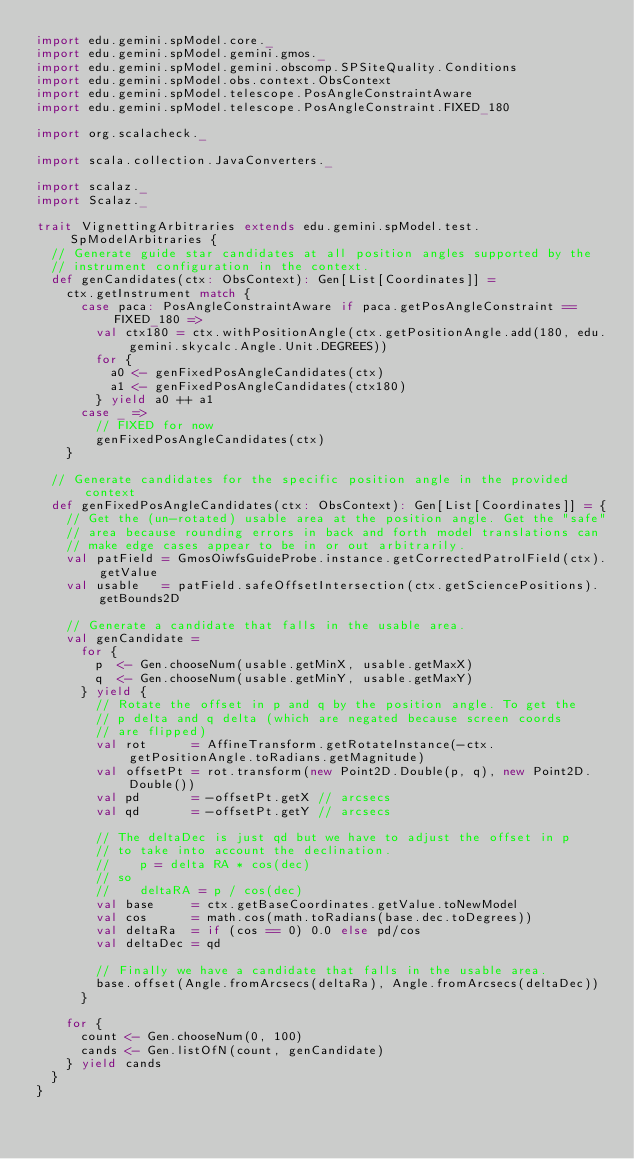Convert code to text. <code><loc_0><loc_0><loc_500><loc_500><_Scala_>import edu.gemini.spModel.core._
import edu.gemini.spModel.gemini.gmos._
import edu.gemini.spModel.gemini.obscomp.SPSiteQuality.Conditions
import edu.gemini.spModel.obs.context.ObsContext
import edu.gemini.spModel.telescope.PosAngleConstraintAware
import edu.gemini.spModel.telescope.PosAngleConstraint.FIXED_180

import org.scalacheck._

import scala.collection.JavaConverters._

import scalaz._
import Scalaz._

trait VignettingArbitraries extends edu.gemini.spModel.test.SpModelArbitraries {
  // Generate guide star candidates at all position angles supported by the
  // instrument configuration in the context.
  def genCandidates(ctx: ObsContext): Gen[List[Coordinates]] =
    ctx.getInstrument match {
      case paca: PosAngleConstraintAware if paca.getPosAngleConstraint == FIXED_180 =>
        val ctx180 = ctx.withPositionAngle(ctx.getPositionAngle.add(180, edu.gemini.skycalc.Angle.Unit.DEGREES))
        for {
          a0 <- genFixedPosAngleCandidates(ctx)
          a1 <- genFixedPosAngleCandidates(ctx180)
        } yield a0 ++ a1
      case _ =>
        // FIXED for now
        genFixedPosAngleCandidates(ctx)
    }

  // Generate candidates for the specific position angle in the provided context
  def genFixedPosAngleCandidates(ctx: ObsContext): Gen[List[Coordinates]] = {
    // Get the (un-rotated) usable area at the position angle. Get the "safe"
    // area because rounding errors in back and forth model translations can
    // make edge cases appear to be in or out arbitrarily.
    val patField = GmosOiwfsGuideProbe.instance.getCorrectedPatrolField(ctx).getValue
    val usable   = patField.safeOffsetIntersection(ctx.getSciencePositions).getBounds2D

    // Generate a candidate that falls in the usable area.
    val genCandidate =
      for {
        p  <- Gen.chooseNum(usable.getMinX, usable.getMaxX)
        q  <- Gen.chooseNum(usable.getMinY, usable.getMaxY)
      } yield {
        // Rotate the offset in p and q by the position angle. To get the
        // p delta and q delta (which are negated because screen coords
        // are flipped)
        val rot      = AffineTransform.getRotateInstance(-ctx.getPositionAngle.toRadians.getMagnitude)
        val offsetPt = rot.transform(new Point2D.Double(p, q), new Point2D.Double())
        val pd       = -offsetPt.getX // arcsecs
        val qd       = -offsetPt.getY // arcsecs

        // The deltaDec is just qd but we have to adjust the offset in p
        // to take into account the declination.
        //    p = delta RA * cos(dec)
        // so
        //    deltaRA = p / cos(dec)
        val base     = ctx.getBaseCoordinates.getValue.toNewModel
        val cos      = math.cos(math.toRadians(base.dec.toDegrees))
        val deltaRa  = if (cos == 0) 0.0 else pd/cos
        val deltaDec = qd

        // Finally we have a candidate that falls in the usable area.
        base.offset(Angle.fromArcsecs(deltaRa), Angle.fromArcsecs(deltaDec))
      }

    for {
      count <- Gen.chooseNum(0, 100)
      cands <- Gen.listOfN(count, genCandidate)
    } yield cands
  }
}
</code> 